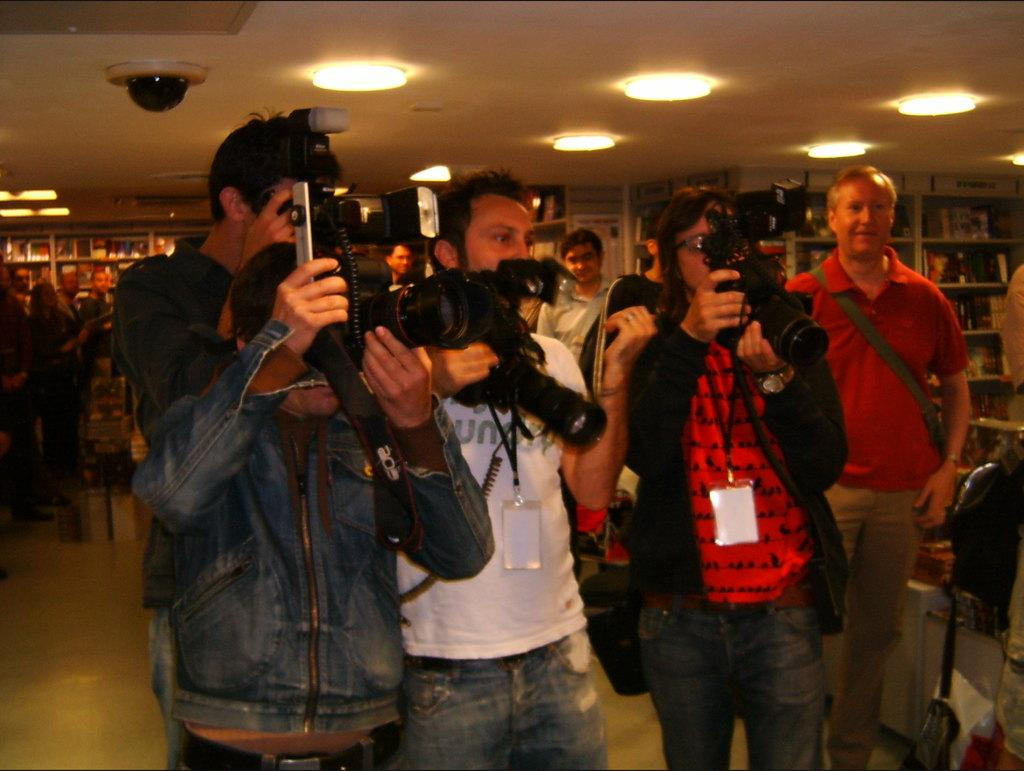What are the people in the room doing? The people in the room are standing and holding cameras. What can be seen on the people's clothing? The people are wearing ID cards. What is located at the back of the room? There are books on the bookshelves at the back of the room. What is providing light in the room? There are lights at the top of the room. Can you describe the jellyfish swimming near the side of the room? There are no jellyfish present in the image; it features people standing in a room with bookshelves and lights. 